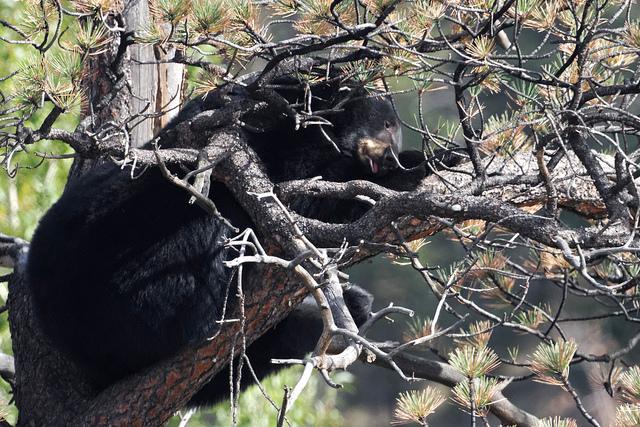Where is the grizzly bear laying?
Keep it brief. Tree. Is this a grizzly bear?
Be succinct. No. What color is the bear?
Short answer required. Black. 